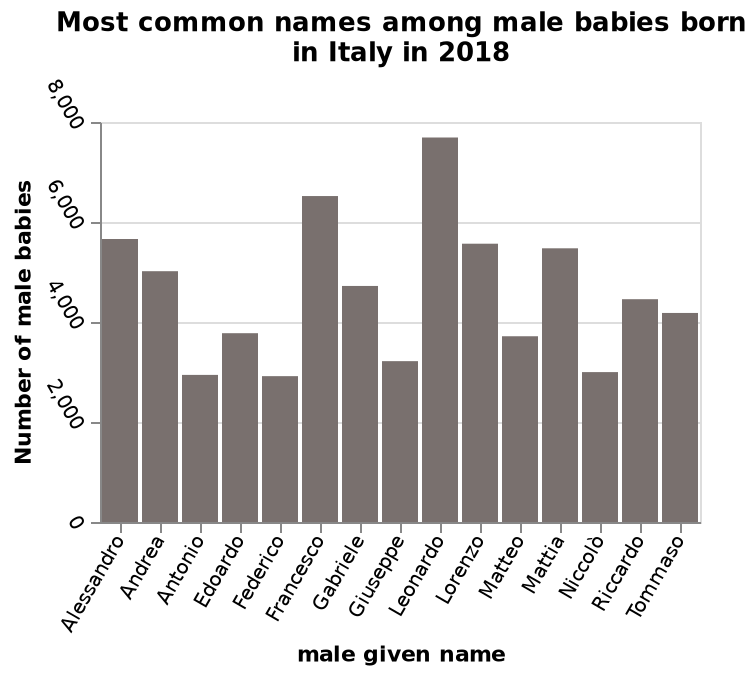<image>
How many increments are there on the Y-axis? There are 5 increments on the Y-axis, each with a value of 2000. What is the most popular name in the list?  Leonardo Describe the following image in detail This bar chart is named Most common names among male babies born in Italy in 2018. A linear scale from 0 to 8,000 can be seen on the y-axis, labeled Number of male babies. A categorical scale starting at Alessandro and ending at Tommaso can be seen on the x-axis, labeled male given name. 